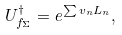Convert formula to latex. <formula><loc_0><loc_0><loc_500><loc_500>U ^ { \dagger } _ { f _ { \Sigma } } = e ^ { \sum v _ { n } L _ { n } } ,</formula> 